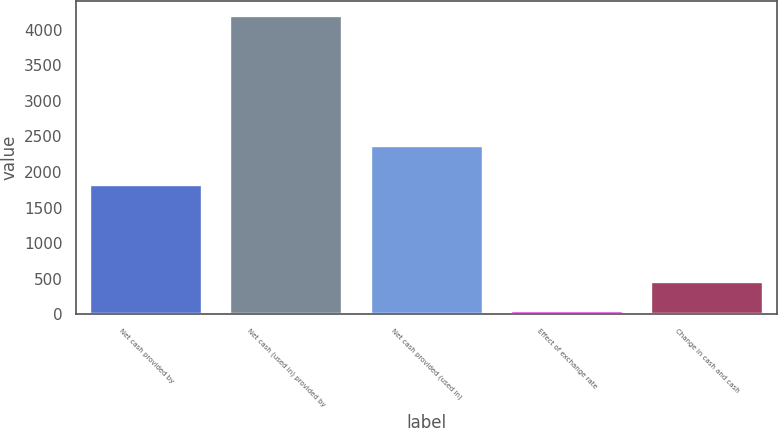Convert chart to OTSL. <chart><loc_0><loc_0><loc_500><loc_500><bar_chart><fcel>Net cash provided by<fcel>Net cash (used in) provided by<fcel>Net cash provided (used in)<fcel>Effect of exchange rate<fcel>Change in cash and cash<nl><fcel>1812<fcel>4191<fcel>2361<fcel>45<fcel>459.6<nl></chart> 